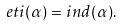Convert formula to latex. <formula><loc_0><loc_0><loc_500><loc_500>e t i ( \alpha ) = i n d ( \alpha ) .</formula> 